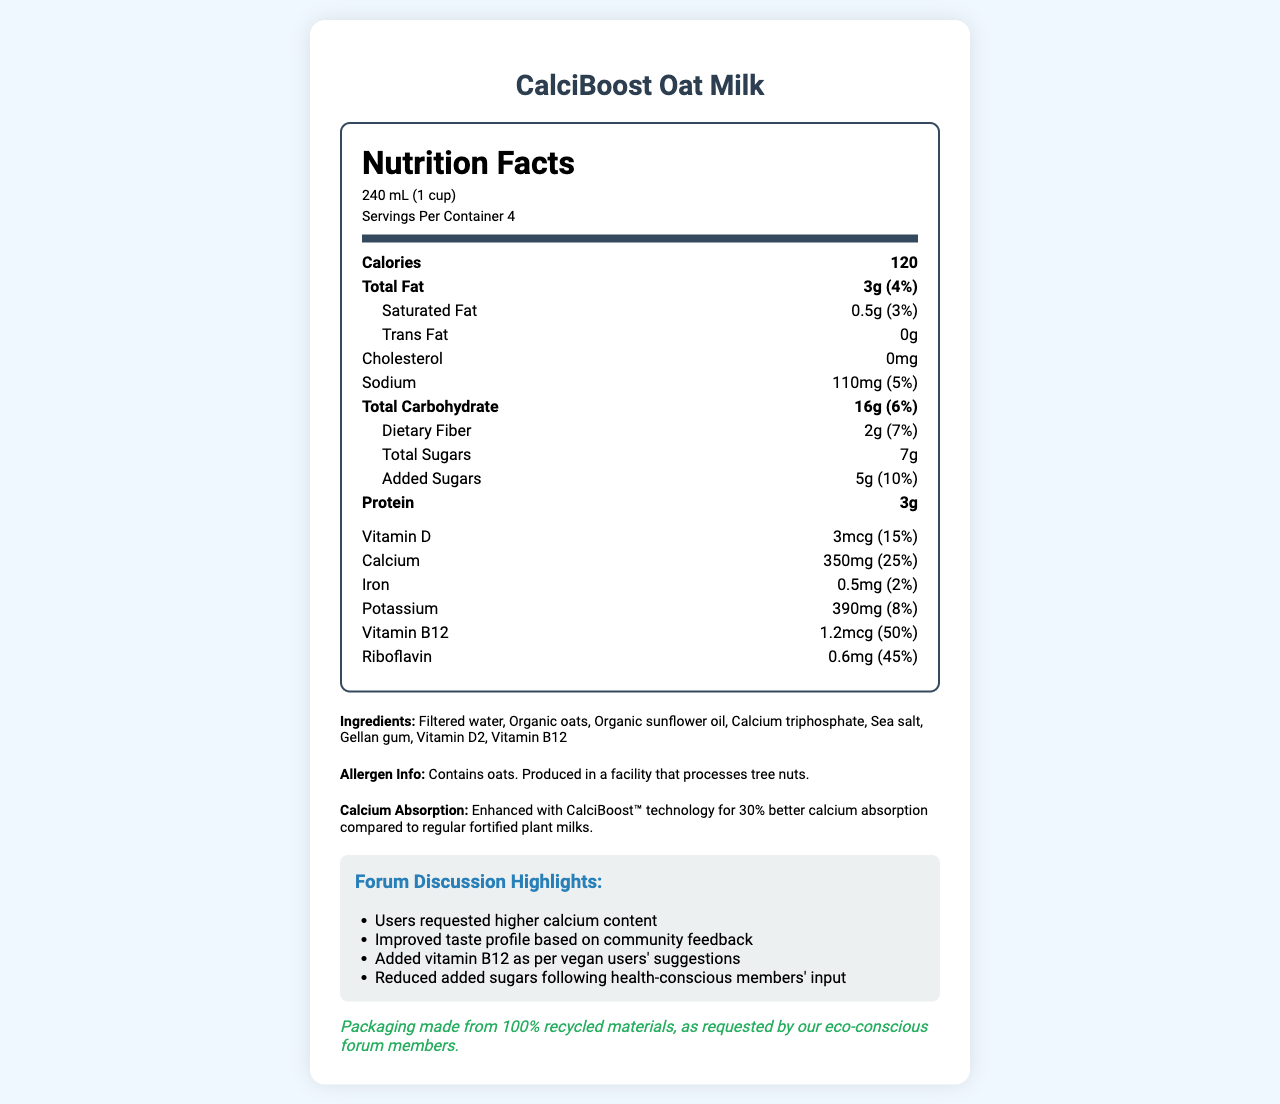what is the serving size? The serving size is mentioned in the "serving-info" section and is specified as 240 mL (1 cup).
Answer: 240 mL (1 cup) how many calories are there per serving? The calories per serving are listed in the "nutrition-item bold" section as 120.
Answer: 120 what percentage of the daily value of calcium does one serving provide? The percentage of daily value for calcium is mentioned next to the calcium amount in the nutrition-label section as 25%.
Answer: 25% what are the total carbohydrates per serving? The total carbohydrates amount is listed in the "nutrition-item bold" section as 16g.
Answer: 16g how many grams of added sugars are there? The added sugars amount is listed under the "sub-item" within carbohydrates as 5g.
Answer: 5g which vitamin has the highest daily value percentage?  
A. Vitamin D  
B. Calcium  
C. Vitamin B12  
D. Riboflavin Vitamin B12 has a daily value of 50%, which is the highest among the vitamins listed.
Answer: C. Vitamin B12 which ingredient is listed first?  
I. Organic oats  
II. Filtered water  
III. Organic sunflower oil  
IV. Calcium triphosphate The ingredient list starts with "Filtered water."
Answer: II. Filtered water does this product contain any cholesterol? The cholesterol amount is listed as 0mg, indicating that it contains no cholesterol.
Answer: No is the product suitable for someone with a tree nut allergy? The allergen information mentions that the product is produced in a facility that processes tree nuts, which poses a risk for someone with a tree nut allergy.
Answer: No summarize the key features of CalciBoost Oat Milk. This summary details the product's nutritional content, special features like enhanced calcium absorption, added vitamins, improved taste, sustainability aspects, and allergen information.
Answer: CalciBoost Oat Milk is a plant-based milk alternative with enhanced calcium absorption, providing 120 calories per serving. It contains 3g of total fat, 16g of carbohydrates, and 3g of protein. The product offers significant amounts of Vitamin B12 and Riboflavin, and it has improved taste and reduced added sugars. It's packaged in 100% recycled materials. does this product taste like regular milk? The document does not provide information about the taste comparison between CalciBoost Oat Milk and regular milk.
Answer: Not enough information 